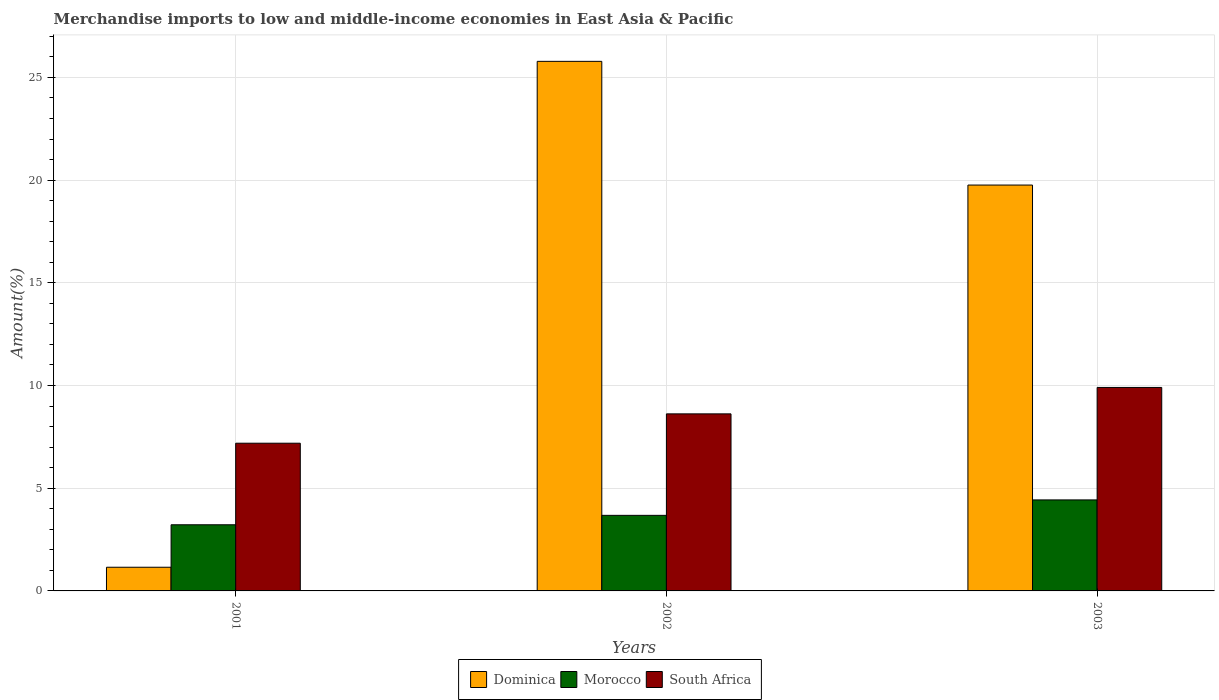Are the number of bars per tick equal to the number of legend labels?
Your answer should be very brief. Yes. How many bars are there on the 3rd tick from the left?
Your answer should be compact. 3. What is the label of the 3rd group of bars from the left?
Your response must be concise. 2003. In how many cases, is the number of bars for a given year not equal to the number of legend labels?
Provide a succinct answer. 0. What is the percentage of amount earned from merchandise imports in Morocco in 2002?
Offer a very short reply. 3.68. Across all years, what is the maximum percentage of amount earned from merchandise imports in South Africa?
Ensure brevity in your answer.  9.91. Across all years, what is the minimum percentage of amount earned from merchandise imports in South Africa?
Keep it short and to the point. 7.19. In which year was the percentage of amount earned from merchandise imports in Morocco maximum?
Provide a short and direct response. 2003. What is the total percentage of amount earned from merchandise imports in Morocco in the graph?
Your answer should be compact. 11.33. What is the difference between the percentage of amount earned from merchandise imports in Dominica in 2001 and that in 2002?
Ensure brevity in your answer.  -24.63. What is the difference between the percentage of amount earned from merchandise imports in South Africa in 2003 and the percentage of amount earned from merchandise imports in Dominica in 2001?
Ensure brevity in your answer.  8.75. What is the average percentage of amount earned from merchandise imports in South Africa per year?
Give a very brief answer. 8.57. In the year 2003, what is the difference between the percentage of amount earned from merchandise imports in Morocco and percentage of amount earned from merchandise imports in South Africa?
Provide a short and direct response. -5.48. What is the ratio of the percentage of amount earned from merchandise imports in South Africa in 2001 to that in 2002?
Keep it short and to the point. 0.83. Is the percentage of amount earned from merchandise imports in Dominica in 2001 less than that in 2003?
Keep it short and to the point. Yes. What is the difference between the highest and the second highest percentage of amount earned from merchandise imports in Dominica?
Your answer should be compact. 6.02. What is the difference between the highest and the lowest percentage of amount earned from merchandise imports in South Africa?
Keep it short and to the point. 2.72. In how many years, is the percentage of amount earned from merchandise imports in Morocco greater than the average percentage of amount earned from merchandise imports in Morocco taken over all years?
Your response must be concise. 1. Is the sum of the percentage of amount earned from merchandise imports in Dominica in 2001 and 2003 greater than the maximum percentage of amount earned from merchandise imports in Morocco across all years?
Provide a succinct answer. Yes. What does the 3rd bar from the left in 2002 represents?
Your response must be concise. South Africa. What does the 1st bar from the right in 2003 represents?
Your answer should be very brief. South Africa. Are all the bars in the graph horizontal?
Ensure brevity in your answer.  No. How many years are there in the graph?
Your response must be concise. 3. Does the graph contain any zero values?
Ensure brevity in your answer.  No. Where does the legend appear in the graph?
Offer a very short reply. Bottom center. How are the legend labels stacked?
Provide a succinct answer. Horizontal. What is the title of the graph?
Provide a succinct answer. Merchandise imports to low and middle-income economies in East Asia & Pacific. What is the label or title of the Y-axis?
Offer a very short reply. Amount(%). What is the Amount(%) of Dominica in 2001?
Offer a very short reply. 1.15. What is the Amount(%) in Morocco in 2001?
Offer a very short reply. 3.22. What is the Amount(%) of South Africa in 2001?
Your answer should be compact. 7.19. What is the Amount(%) in Dominica in 2002?
Keep it short and to the point. 25.78. What is the Amount(%) in Morocco in 2002?
Offer a very short reply. 3.68. What is the Amount(%) of South Africa in 2002?
Your answer should be very brief. 8.62. What is the Amount(%) of Dominica in 2003?
Your response must be concise. 19.76. What is the Amount(%) in Morocco in 2003?
Make the answer very short. 4.43. What is the Amount(%) in South Africa in 2003?
Offer a very short reply. 9.91. Across all years, what is the maximum Amount(%) in Dominica?
Keep it short and to the point. 25.78. Across all years, what is the maximum Amount(%) of Morocco?
Keep it short and to the point. 4.43. Across all years, what is the maximum Amount(%) in South Africa?
Your response must be concise. 9.91. Across all years, what is the minimum Amount(%) of Dominica?
Make the answer very short. 1.15. Across all years, what is the minimum Amount(%) of Morocco?
Your answer should be very brief. 3.22. Across all years, what is the minimum Amount(%) in South Africa?
Your response must be concise. 7.19. What is the total Amount(%) in Dominica in the graph?
Provide a succinct answer. 46.69. What is the total Amount(%) in Morocco in the graph?
Keep it short and to the point. 11.33. What is the total Amount(%) in South Africa in the graph?
Provide a short and direct response. 25.72. What is the difference between the Amount(%) in Dominica in 2001 and that in 2002?
Offer a terse response. -24.63. What is the difference between the Amount(%) of Morocco in 2001 and that in 2002?
Give a very brief answer. -0.46. What is the difference between the Amount(%) of South Africa in 2001 and that in 2002?
Make the answer very short. -1.43. What is the difference between the Amount(%) of Dominica in 2001 and that in 2003?
Ensure brevity in your answer.  -18.61. What is the difference between the Amount(%) in Morocco in 2001 and that in 2003?
Ensure brevity in your answer.  -1.21. What is the difference between the Amount(%) in South Africa in 2001 and that in 2003?
Your answer should be compact. -2.72. What is the difference between the Amount(%) of Dominica in 2002 and that in 2003?
Keep it short and to the point. 6.02. What is the difference between the Amount(%) in Morocco in 2002 and that in 2003?
Offer a terse response. -0.75. What is the difference between the Amount(%) in South Africa in 2002 and that in 2003?
Offer a terse response. -1.29. What is the difference between the Amount(%) in Dominica in 2001 and the Amount(%) in Morocco in 2002?
Offer a very short reply. -2.53. What is the difference between the Amount(%) in Dominica in 2001 and the Amount(%) in South Africa in 2002?
Your response must be concise. -7.47. What is the difference between the Amount(%) in Morocco in 2001 and the Amount(%) in South Africa in 2002?
Keep it short and to the point. -5.4. What is the difference between the Amount(%) of Dominica in 2001 and the Amount(%) of Morocco in 2003?
Give a very brief answer. -3.28. What is the difference between the Amount(%) in Dominica in 2001 and the Amount(%) in South Africa in 2003?
Your answer should be very brief. -8.75. What is the difference between the Amount(%) of Morocco in 2001 and the Amount(%) of South Africa in 2003?
Keep it short and to the point. -6.69. What is the difference between the Amount(%) of Dominica in 2002 and the Amount(%) of Morocco in 2003?
Provide a succinct answer. 21.35. What is the difference between the Amount(%) in Dominica in 2002 and the Amount(%) in South Africa in 2003?
Provide a succinct answer. 15.88. What is the difference between the Amount(%) of Morocco in 2002 and the Amount(%) of South Africa in 2003?
Ensure brevity in your answer.  -6.23. What is the average Amount(%) in Dominica per year?
Your answer should be compact. 15.56. What is the average Amount(%) of Morocco per year?
Offer a very short reply. 3.78. What is the average Amount(%) in South Africa per year?
Offer a very short reply. 8.57. In the year 2001, what is the difference between the Amount(%) of Dominica and Amount(%) of Morocco?
Offer a very short reply. -2.07. In the year 2001, what is the difference between the Amount(%) in Dominica and Amount(%) in South Africa?
Provide a short and direct response. -6.04. In the year 2001, what is the difference between the Amount(%) of Morocco and Amount(%) of South Africa?
Ensure brevity in your answer.  -3.97. In the year 2002, what is the difference between the Amount(%) in Dominica and Amount(%) in Morocco?
Your response must be concise. 22.1. In the year 2002, what is the difference between the Amount(%) of Dominica and Amount(%) of South Africa?
Provide a succinct answer. 17.16. In the year 2002, what is the difference between the Amount(%) of Morocco and Amount(%) of South Africa?
Your response must be concise. -4.94. In the year 2003, what is the difference between the Amount(%) in Dominica and Amount(%) in Morocco?
Ensure brevity in your answer.  15.33. In the year 2003, what is the difference between the Amount(%) in Dominica and Amount(%) in South Africa?
Your answer should be very brief. 9.85. In the year 2003, what is the difference between the Amount(%) of Morocco and Amount(%) of South Africa?
Offer a very short reply. -5.48. What is the ratio of the Amount(%) of Dominica in 2001 to that in 2002?
Provide a succinct answer. 0.04. What is the ratio of the Amount(%) in Morocco in 2001 to that in 2002?
Your answer should be very brief. 0.88. What is the ratio of the Amount(%) in South Africa in 2001 to that in 2002?
Offer a very short reply. 0.83. What is the ratio of the Amount(%) in Dominica in 2001 to that in 2003?
Give a very brief answer. 0.06. What is the ratio of the Amount(%) of Morocco in 2001 to that in 2003?
Offer a very short reply. 0.73. What is the ratio of the Amount(%) in South Africa in 2001 to that in 2003?
Ensure brevity in your answer.  0.73. What is the ratio of the Amount(%) of Dominica in 2002 to that in 2003?
Offer a terse response. 1.3. What is the ratio of the Amount(%) of Morocco in 2002 to that in 2003?
Offer a terse response. 0.83. What is the ratio of the Amount(%) in South Africa in 2002 to that in 2003?
Your response must be concise. 0.87. What is the difference between the highest and the second highest Amount(%) in Dominica?
Provide a succinct answer. 6.02. What is the difference between the highest and the second highest Amount(%) in Morocco?
Provide a succinct answer. 0.75. What is the difference between the highest and the second highest Amount(%) in South Africa?
Provide a short and direct response. 1.29. What is the difference between the highest and the lowest Amount(%) in Dominica?
Your response must be concise. 24.63. What is the difference between the highest and the lowest Amount(%) of Morocco?
Make the answer very short. 1.21. What is the difference between the highest and the lowest Amount(%) of South Africa?
Give a very brief answer. 2.72. 